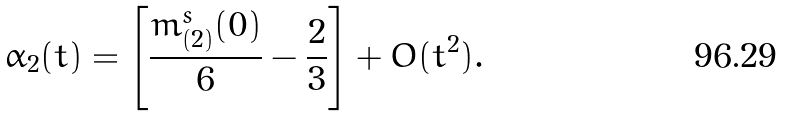Convert formula to latex. <formula><loc_0><loc_0><loc_500><loc_500>\alpha _ { 2 } ( t ) = \left [ \frac { m _ { ( 2 ) } ^ { s } ( 0 ) } { 6 } - \frac { 2 } { 3 } \right ] + O ( t ^ { 2 } ) .</formula> 